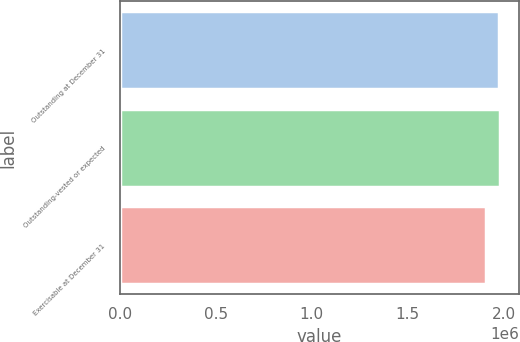Convert chart. <chart><loc_0><loc_0><loc_500><loc_500><bar_chart><fcel>Outstanding at December 31<fcel>Outstanding-vested or expected<fcel>Exercisable at December 31<nl><fcel>1.9733e+06<fcel>1.9801e+06<fcel>1.90532e+06<nl></chart> 